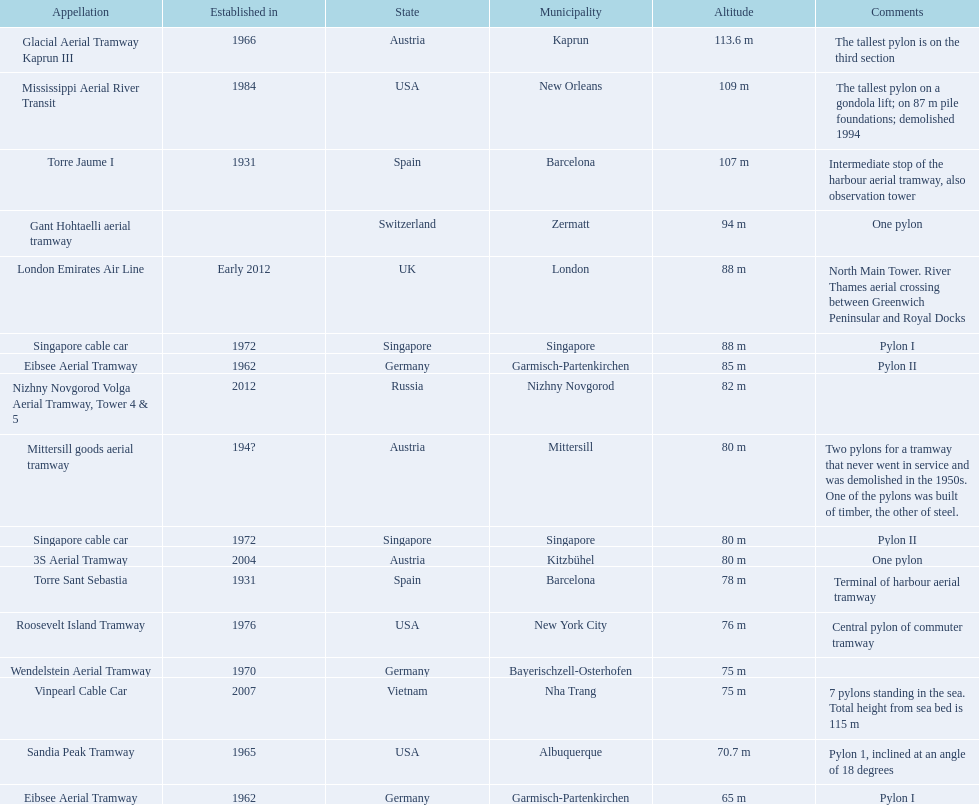How many metres is the tallest pylon? 113.6 m. 